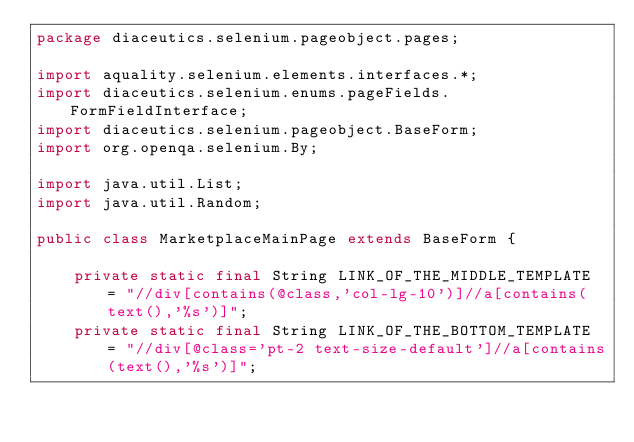<code> <loc_0><loc_0><loc_500><loc_500><_Java_>package diaceutics.selenium.pageobject.pages;

import aquality.selenium.elements.interfaces.*;
import diaceutics.selenium.enums.pageFields.FormFieldInterface;
import diaceutics.selenium.pageobject.BaseForm;
import org.openqa.selenium.By;

import java.util.List;
import java.util.Random;

public class MarketplaceMainPage extends BaseForm {

    private static final String LINK_OF_THE_MIDDLE_TEMPLATE = "//div[contains(@class,'col-lg-10')]//a[contains(text(),'%s')]";
    private static final String LINK_OF_THE_BOTTOM_TEMPLATE = "//div[@class='pt-2 text-size-default']//a[contains(text(),'%s')]";</code> 